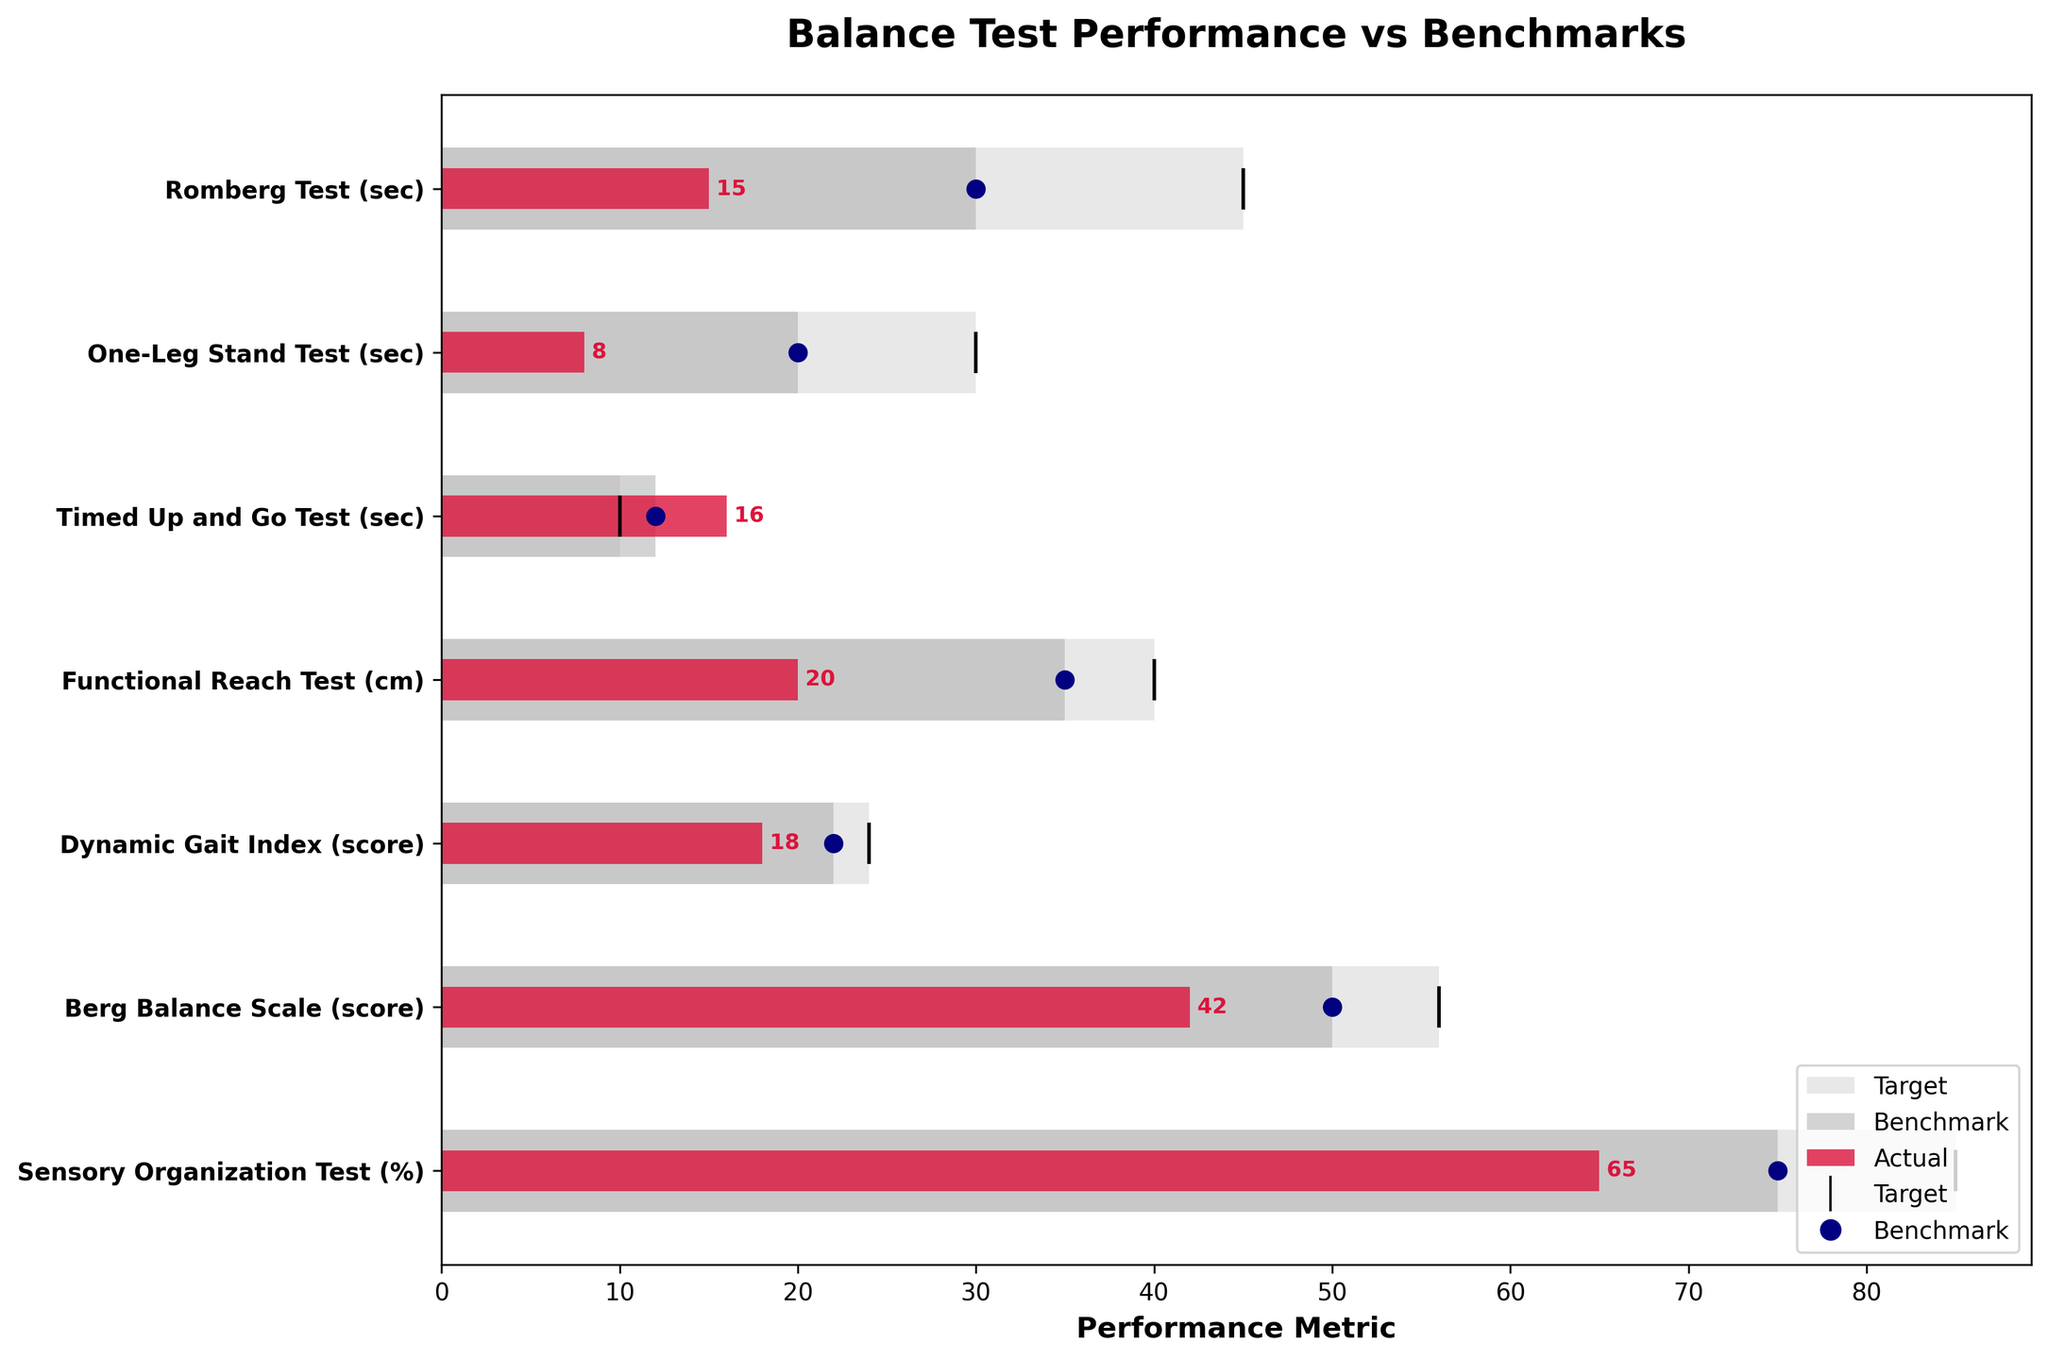What is the title of the figure? The title is prominently located at the top of the figure in larger, bold font, making it easy to identify.
Answer: Balance Test Performance vs Benchmarks How much time difference is there between the benchmark and actual performance in the Romberg Test? Locate the Romberg Test on the vertical axis, then read off the values for the actual performance (15 seconds) and the benchmark (30 seconds). Subtract the actual performance from the benchmark.
Answer: 15 seconds How does the actual score in the Berg Balance Scale compare to its benchmark? Find the Berg Balance Scale on the vertical axis and compare the actual score (42) against the benchmark score (50). The actual score is below the benchmark.
Answer: Below Which test shows the largest gap between the actual and target values? Calculate the difference between the actual value and the target value for each test. Identify the test with the highest difference.
Answer: Timed Up and Go Test What is your score in the One-Leg Stand Test compared to the benchmark? Locate the One-Leg Stand Test on the vertical axis and compare the actual performance (8 seconds) to the benchmark (20 seconds). The actual performance is below the benchmark.
Answer: Below Which test involves times being measured in seconds? Refer to the labels on the vertical axis to identify which tests use seconds as their performance metrics.
Answer: Romberg Test, One-Leg Stand Test, Timed Up and Go Test What percentage point difference is there between the actual performance and the target in the Sensory Organization Test? Identify the Sensory Organization Test on the vertical axis and compare the actual performance (65%) with the target (85%). Calculate the percentage point difference.
Answer: 20 percentage points 